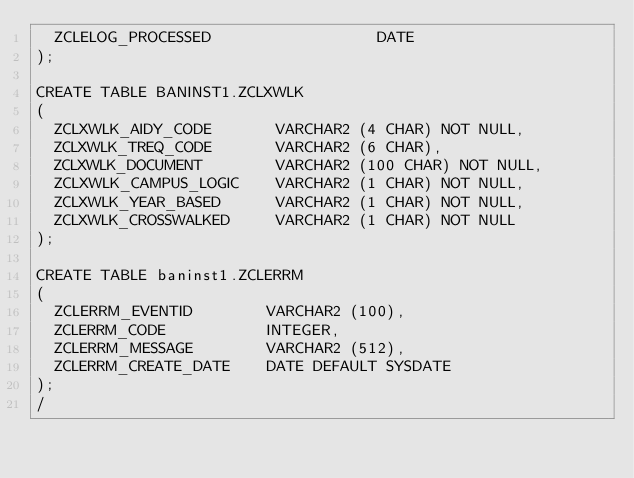<code> <loc_0><loc_0><loc_500><loc_500><_SQL_>  ZCLELOG_PROCESSED                  DATE
);

CREATE TABLE BANINST1.ZCLXWLK
(
  ZCLXWLK_AIDY_CODE       VARCHAR2 (4 CHAR) NOT NULL,
  ZCLXWLK_TREQ_CODE       VARCHAR2 (6 CHAR),
  ZCLXWLK_DOCUMENT        VARCHAR2 (100 CHAR) NOT NULL,
  ZCLXWLK_CAMPUS_LOGIC    VARCHAR2 (1 CHAR) NOT NULL,
  ZCLXWLK_YEAR_BASED      VARCHAR2 (1 CHAR) NOT NULL,
  ZCLXWLK_CROSSWALKED     VARCHAR2 (1 CHAR) NOT NULL
);

CREATE TABLE baninst1.ZCLERRM
(
  ZCLERRM_EVENTID        VARCHAR2 (100),
  ZCLERRM_CODE           INTEGER,
  ZCLERRM_MESSAGE        VARCHAR2 (512),
  ZCLERRM_CREATE_DATE    DATE DEFAULT SYSDATE
);
/</code> 